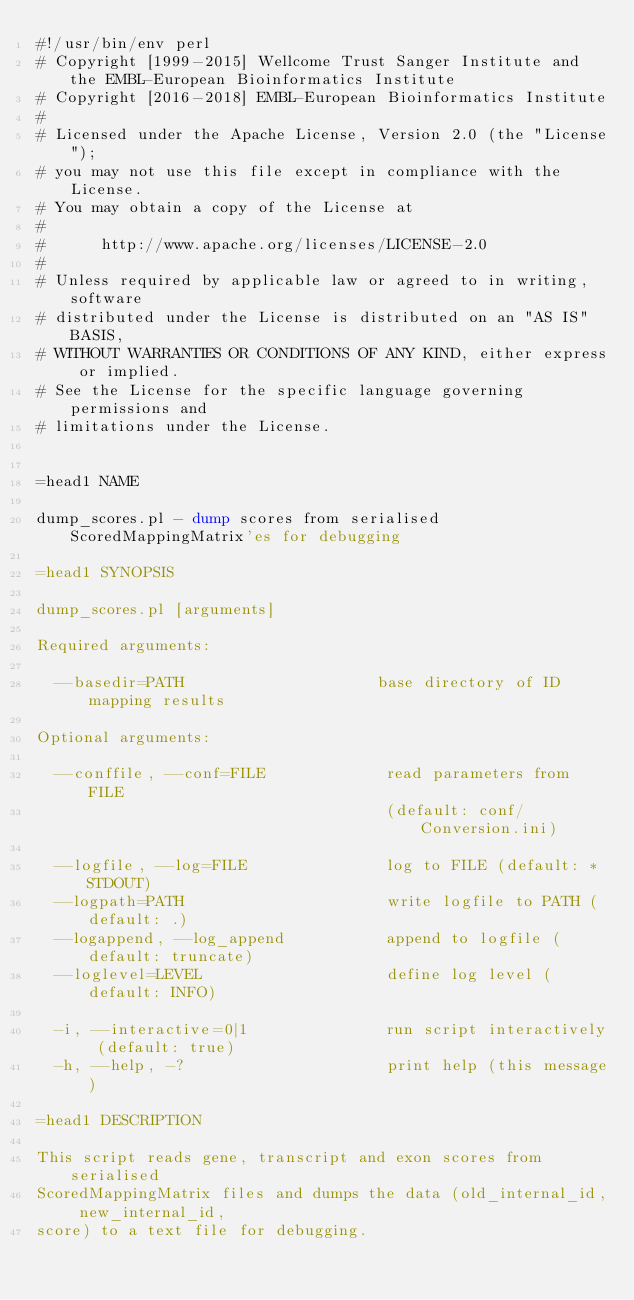<code> <loc_0><loc_0><loc_500><loc_500><_Perl_>#!/usr/bin/env perl
# Copyright [1999-2015] Wellcome Trust Sanger Institute and the EMBL-European Bioinformatics Institute
# Copyright [2016-2018] EMBL-European Bioinformatics Institute
# 
# Licensed under the Apache License, Version 2.0 (the "License");
# you may not use this file except in compliance with the License.
# You may obtain a copy of the License at
# 
#      http://www.apache.org/licenses/LICENSE-2.0
# 
# Unless required by applicable law or agreed to in writing, software
# distributed under the License is distributed on an "AS IS" BASIS,
# WITHOUT WARRANTIES OR CONDITIONS OF ANY KIND, either express or implied.
# See the License for the specific language governing permissions and
# limitations under the License.


=head1 NAME

dump_scores.pl - dump scores from serialised ScoredMappingMatrix'es for debugging

=head1 SYNOPSIS

dump_scores.pl [arguments]

Required arguments:

  --basedir=PATH                     base directory of ID mapping results

Optional arguments:

  --conffile, --conf=FILE             read parameters from FILE
                                      (default: conf/Conversion.ini)

  --logfile, --log=FILE               log to FILE (default: *STDOUT)
  --logpath=PATH                      write logfile to PATH (default: .)
  --logappend, --log_append           append to logfile (default: truncate)
  --loglevel=LEVEL                    define log level (default: INFO)

  -i, --interactive=0|1               run script interactively (default: true)
  -h, --help, -?                      print help (this message)

=head1 DESCRIPTION

This script reads gene, transcript and exon scores from serialised
ScoredMappingMatrix files and dumps the data (old_internal_id, new_internal_id,
score) to a text file for debugging.
</code> 